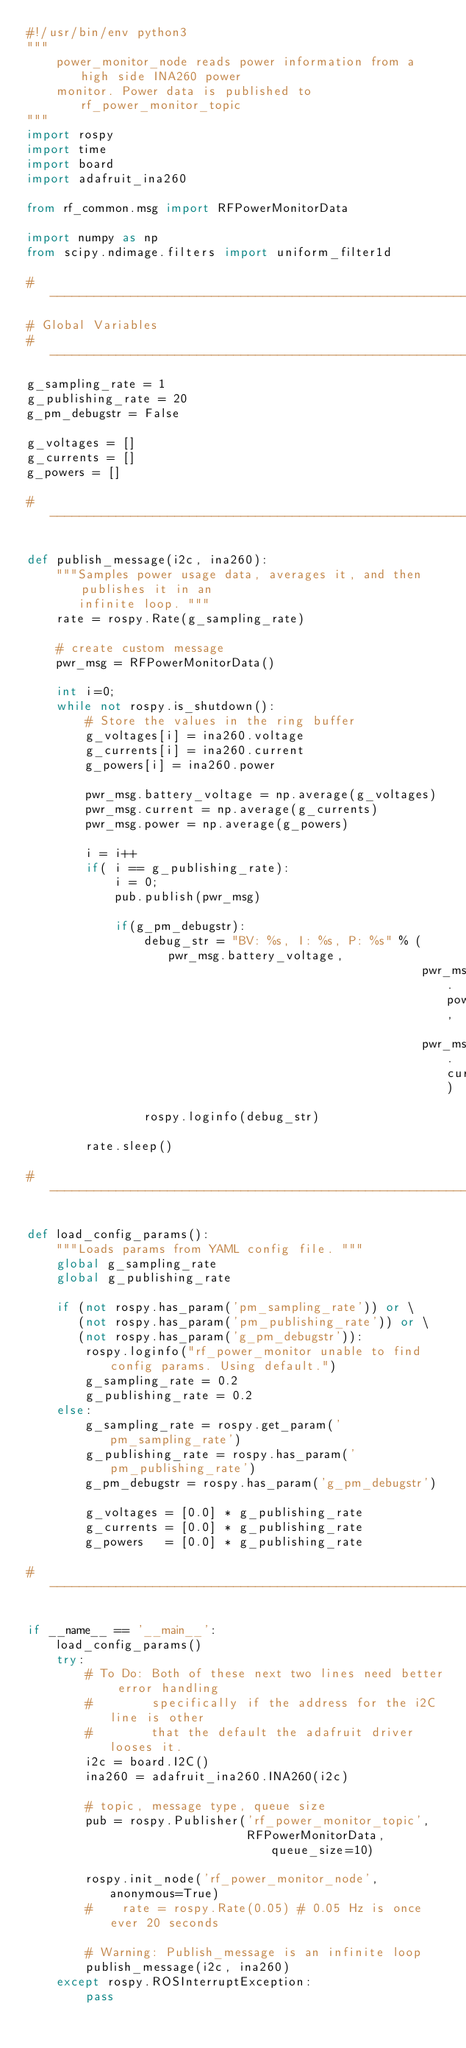<code> <loc_0><loc_0><loc_500><loc_500><_Python_>#!/usr/bin/env python3
""" 
    power_monitor_node reads power information from a high side INA260 power 
    monitor. Power data is published to rf_power_monitor_topic
"""
import rospy
import time
import board
import adafruit_ina260

from rf_common.msg import RFPowerMonitorData

import numpy as np
from scipy.ndimage.filters import uniform_filter1d

#-------------------------------------------------------------------------------
# Global Variables
#-------------------------------------------------------------------------------
g_sampling_rate = 1
g_publishing_rate = 20
g_pm_debugstr = False

g_voltages = []
g_currents = []
g_powers = []

#-------------------------------------------------------------------------------

def publish_message(i2c, ina260):
    """Samples power usage data, averages it, and then publishes it in an 
       infinite loop. """
    rate = rospy.Rate(g_sampling_rate) 

    # create custom message
    pwr_msg = RFPowerMonitorData()

    int i=0;
    while not rospy.is_shutdown():
        # Store the values in the ring buffer
        g_voltages[i] = ina260.voltage 
        g_currents[i] = ina260.current
        g_powers[i] = ina260.power
        
        pwr_msg.battery_voltage = np.average(g_voltages)
        pwr_msg.current = np.average(g_currents)
        pwr_msg.power = np.average(g_powers)
        
        i = i++
        if( i == g_publishing_rate):
            i = 0;
            pub.publish(pwr_msg)

            if(g_pm_debugstr):
                debug_str = "BV: %s, I: %s, P: %s" % (pwr_msg.battery_voltage,
                                                      pwr_msg.power,
                                                      pwr_msg.current)
                rospy.loginfo(debug_str)
            
        rate.sleep()

#-------------------------------------------------------------------------------

def load_config_params():
    """Loads params from YAML config file. """
    global g_sampling_rate
    global g_publishing_rate
    
    if (not rospy.has_param('pm_sampling_rate')) or \
       (not rospy.has_param('pm_publishing_rate')) or \
       (not rospy.has_param('g_pm_debugstr')):
        rospy.loginfo("rf_power_monitor unable to find config params. Using default.")
        g_sampling_rate = 0.2
        g_publishing_rate = 0.2
    else:
        g_sampling_rate = rospy.get_param('pm_sampling_rate')
        g_publishing_rate = rospy.has_param('pm_publishing_rate')        
        g_pm_debugstr = rospy.has_param('g_pm_debugstr')

        g_voltages = [0.0] * g_publishing_rate
        g_currents = [0.0] * g_publishing_rate
        g_powers   = [0.0] * g_publishing_rate

#-------------------------------------------------------------------------------

if __name__ == '__main__':
    load_config_params()
    try:
        # To Do: Both of these next two lines need better error handling
        #        specifically if the address for the i2C line is other
        #        that the default the adafruit driver looses it. 
        i2c = board.I2C()
        ina260 = adafruit_ina260.INA260(i2c)

        # topic, message type, queue size
        pub = rospy.Publisher('rf_power_monitor_topic',
                              RFPowerMonitorData, queue_size=10)

        rospy.init_node('rf_power_monitor_node', anonymous=True)
        #    rate = rospy.Rate(0.05) # 0.05 Hz is once ever 20 seconds
        
        # Warning: Publish_message is an infinite loop
        publish_message(i2c, ina260)
    except rospy.ROSInterruptException:
        pass
    
</code> 